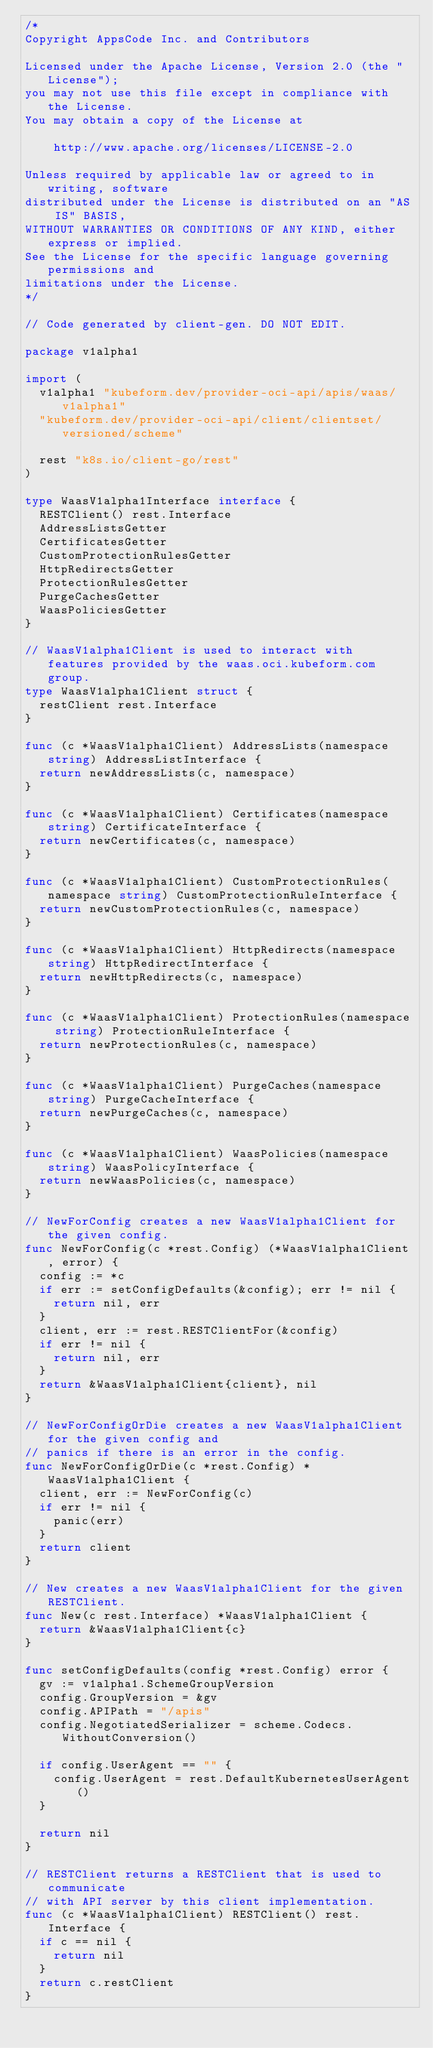<code> <loc_0><loc_0><loc_500><loc_500><_Go_>/*
Copyright AppsCode Inc. and Contributors

Licensed under the Apache License, Version 2.0 (the "License");
you may not use this file except in compliance with the License.
You may obtain a copy of the License at

    http://www.apache.org/licenses/LICENSE-2.0

Unless required by applicable law or agreed to in writing, software
distributed under the License is distributed on an "AS IS" BASIS,
WITHOUT WARRANTIES OR CONDITIONS OF ANY KIND, either express or implied.
See the License for the specific language governing permissions and
limitations under the License.
*/

// Code generated by client-gen. DO NOT EDIT.

package v1alpha1

import (
	v1alpha1 "kubeform.dev/provider-oci-api/apis/waas/v1alpha1"
	"kubeform.dev/provider-oci-api/client/clientset/versioned/scheme"

	rest "k8s.io/client-go/rest"
)

type WaasV1alpha1Interface interface {
	RESTClient() rest.Interface
	AddressListsGetter
	CertificatesGetter
	CustomProtectionRulesGetter
	HttpRedirectsGetter
	ProtectionRulesGetter
	PurgeCachesGetter
	WaasPoliciesGetter
}

// WaasV1alpha1Client is used to interact with features provided by the waas.oci.kubeform.com group.
type WaasV1alpha1Client struct {
	restClient rest.Interface
}

func (c *WaasV1alpha1Client) AddressLists(namespace string) AddressListInterface {
	return newAddressLists(c, namespace)
}

func (c *WaasV1alpha1Client) Certificates(namespace string) CertificateInterface {
	return newCertificates(c, namespace)
}

func (c *WaasV1alpha1Client) CustomProtectionRules(namespace string) CustomProtectionRuleInterface {
	return newCustomProtectionRules(c, namespace)
}

func (c *WaasV1alpha1Client) HttpRedirects(namespace string) HttpRedirectInterface {
	return newHttpRedirects(c, namespace)
}

func (c *WaasV1alpha1Client) ProtectionRules(namespace string) ProtectionRuleInterface {
	return newProtectionRules(c, namespace)
}

func (c *WaasV1alpha1Client) PurgeCaches(namespace string) PurgeCacheInterface {
	return newPurgeCaches(c, namespace)
}

func (c *WaasV1alpha1Client) WaasPolicies(namespace string) WaasPolicyInterface {
	return newWaasPolicies(c, namespace)
}

// NewForConfig creates a new WaasV1alpha1Client for the given config.
func NewForConfig(c *rest.Config) (*WaasV1alpha1Client, error) {
	config := *c
	if err := setConfigDefaults(&config); err != nil {
		return nil, err
	}
	client, err := rest.RESTClientFor(&config)
	if err != nil {
		return nil, err
	}
	return &WaasV1alpha1Client{client}, nil
}

// NewForConfigOrDie creates a new WaasV1alpha1Client for the given config and
// panics if there is an error in the config.
func NewForConfigOrDie(c *rest.Config) *WaasV1alpha1Client {
	client, err := NewForConfig(c)
	if err != nil {
		panic(err)
	}
	return client
}

// New creates a new WaasV1alpha1Client for the given RESTClient.
func New(c rest.Interface) *WaasV1alpha1Client {
	return &WaasV1alpha1Client{c}
}

func setConfigDefaults(config *rest.Config) error {
	gv := v1alpha1.SchemeGroupVersion
	config.GroupVersion = &gv
	config.APIPath = "/apis"
	config.NegotiatedSerializer = scheme.Codecs.WithoutConversion()

	if config.UserAgent == "" {
		config.UserAgent = rest.DefaultKubernetesUserAgent()
	}

	return nil
}

// RESTClient returns a RESTClient that is used to communicate
// with API server by this client implementation.
func (c *WaasV1alpha1Client) RESTClient() rest.Interface {
	if c == nil {
		return nil
	}
	return c.restClient
}
</code> 